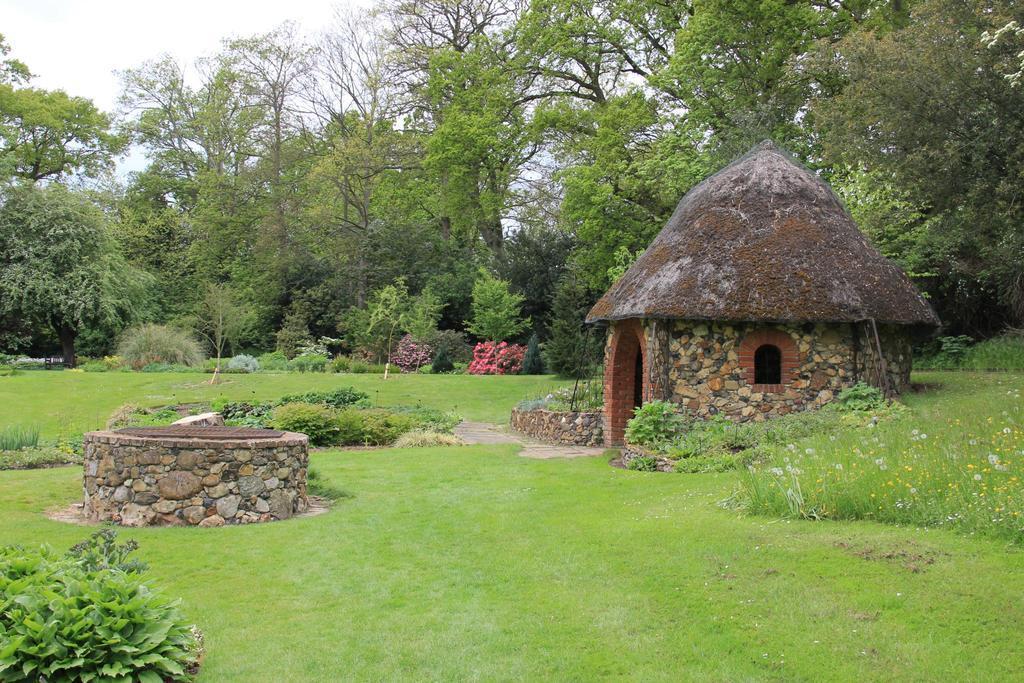In one or two sentences, can you explain what this image depicts? In this picture I can see trees, grass, plants and a house. On the left side I can see a stone object. In the background I can see the sky. 